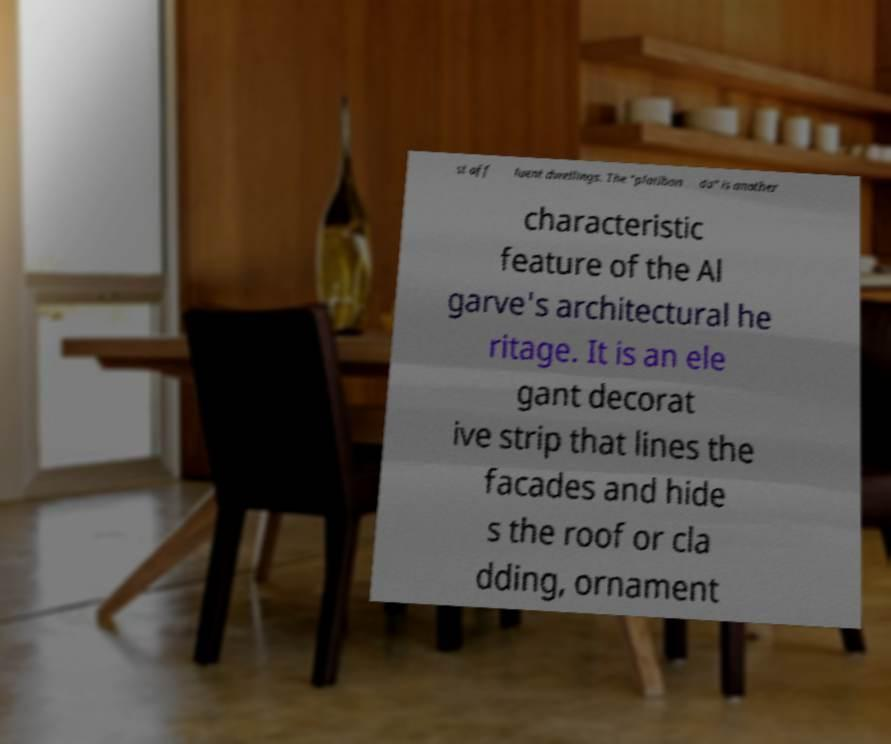Can you accurately transcribe the text from the provided image for me? st aff luent dwellings. The "platiban da" is another characteristic feature of the Al garve's architectural he ritage. It is an ele gant decorat ive strip that lines the facades and hide s the roof or cla dding, ornament 